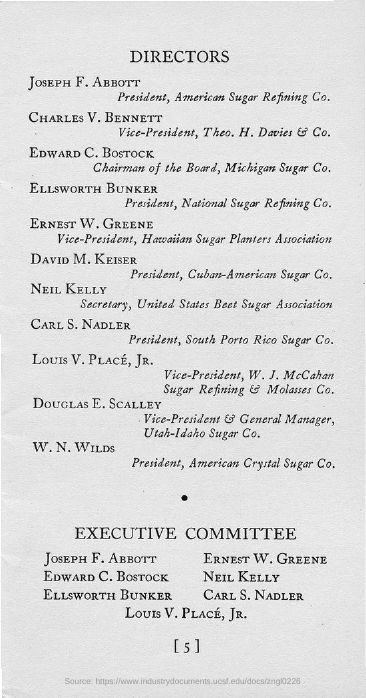Who is the president of American Sugar Refining Co.?
Your answer should be compact. Joseph F. Abbott. Who is the chairman of the board, Michigan Sugar Co.?
Offer a terse response. Edward C. Bostock. 